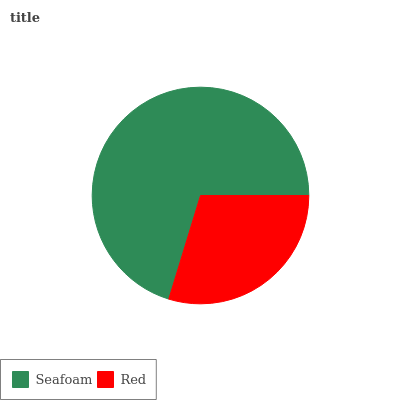Is Red the minimum?
Answer yes or no. Yes. Is Seafoam the maximum?
Answer yes or no. Yes. Is Red the maximum?
Answer yes or no. No. Is Seafoam greater than Red?
Answer yes or no. Yes. Is Red less than Seafoam?
Answer yes or no. Yes. Is Red greater than Seafoam?
Answer yes or no. No. Is Seafoam less than Red?
Answer yes or no. No. Is Seafoam the high median?
Answer yes or no. Yes. Is Red the low median?
Answer yes or no. Yes. Is Red the high median?
Answer yes or no. No. Is Seafoam the low median?
Answer yes or no. No. 